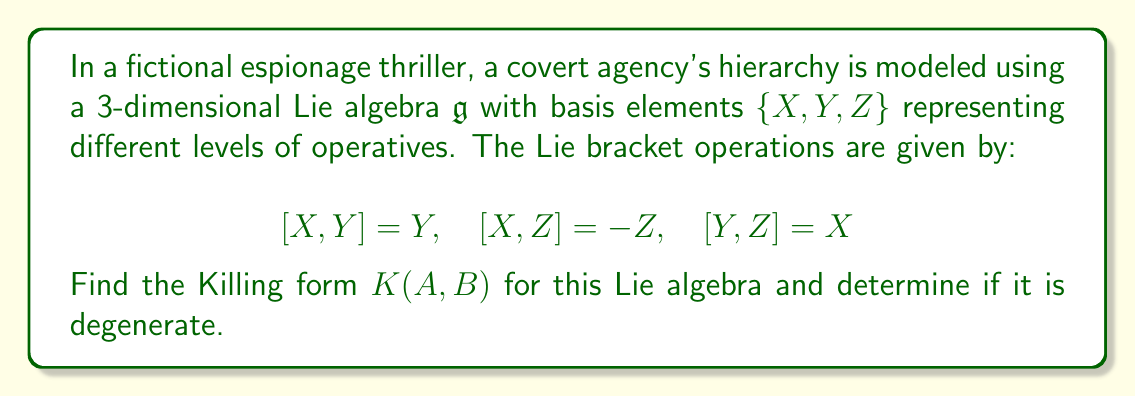Solve this math problem. To find the Killing form for this Lie algebra, we follow these steps:

1) The Killing form is defined as $K(A,B) = \text{tr}(\text{ad}(A) \circ \text{ad}(B))$, where $\text{ad}(A)$ is the adjoint representation of $A$.

2) First, we need to find the matrix representations of $\text{ad}(X)$, $\text{ad}(Y)$, and $\text{ad}(Z)$ with respect to the given basis.

3) For $\text{ad}(X)$:
   $$\text{ad}(X)(X) = 0$$
   $$\text{ad}(X)(Y) = [X,Y] = Y$$
   $$\text{ad}(X)(Z) = [X,Z] = -Z$$
   
   So, $\text{ad}(X) = \begin{pmatrix} 0 & 0 & 0 \\ 0 & 1 & 0 \\ 0 & 0 & -1 \end{pmatrix}$

4) Similarly, for $\text{ad}(Y)$ and $\text{ad}(Z)$:
   
   $\text{ad}(Y) = \begin{pmatrix} 0 & 0 & 1 \\ -1 & 0 & 0 \\ 0 & 0 & 0 \end{pmatrix}$
   
   $\text{ad}(Z) = \begin{pmatrix} 0 & -1 & 0 \\ 0 & 0 & 0 \\ 1 & 0 & 0 \end{pmatrix}$

5) Now, we calculate $K(A,B)$ for all pairs of basis elements:

   $K(X,X) = \text{tr}(\text{ad}(X) \circ \text{ad}(X)) = 0 + 1 + 1 = 2$
   
   $K(Y,Y) = \text{tr}(\text{ad}(Y) \circ \text{ad}(Y)) = 0 + 0 + 1 = 1$
   
   $K(Z,Z) = \text{tr}(\text{ad}(Z) \circ \text{ad}(Z)) = 0 + 1 + 0 = 1$
   
   $K(X,Y) = K(Y,X) = \text{tr}(\text{ad}(X) \circ \text{ad}(Y)) = 0 + 0 + 0 = 0$
   
   $K(X,Z) = K(Z,X) = \text{tr}(\text{ad}(X) \circ \text{ad}(Z)) = 0 + 0 + 0 = 0$
   
   $K(Y,Z) = K(Z,Y) = \text{tr}(\text{ad}(Y) \circ \text{ad}(Z)) = -1 + 0 + 0 = -1$

6) The Killing form matrix is therefore:

   $$K = \begin{pmatrix} 2 & 0 & 0 \\ 0 & 1 & -1 \\ 0 & -1 & 1 \end{pmatrix}$$

7) To determine if the Killing form is degenerate, we calculate its determinant:

   $\det(K) = 2(1 \cdot 1 - (-1) \cdot (-1)) - 0 = 0$

   Since the determinant is zero, the Killing form is degenerate.
Answer: The Killing form for the given Lie algebra is:

$$K = \begin{pmatrix} 2 & 0 & 0 \\ 0 & 1 & -1 \\ 0 & -1 & 1 \end{pmatrix}$$

The Killing form is degenerate as $\det(K) = 0$. 